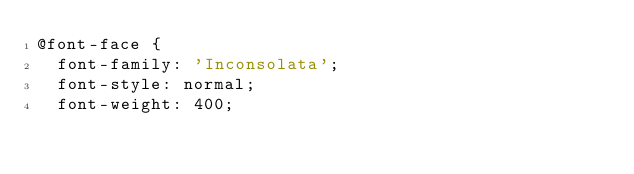<code> <loc_0><loc_0><loc_500><loc_500><_CSS_>@font-face {
  font-family: 'Inconsolata';
  font-style: normal;
  font-weight: 400;</code> 